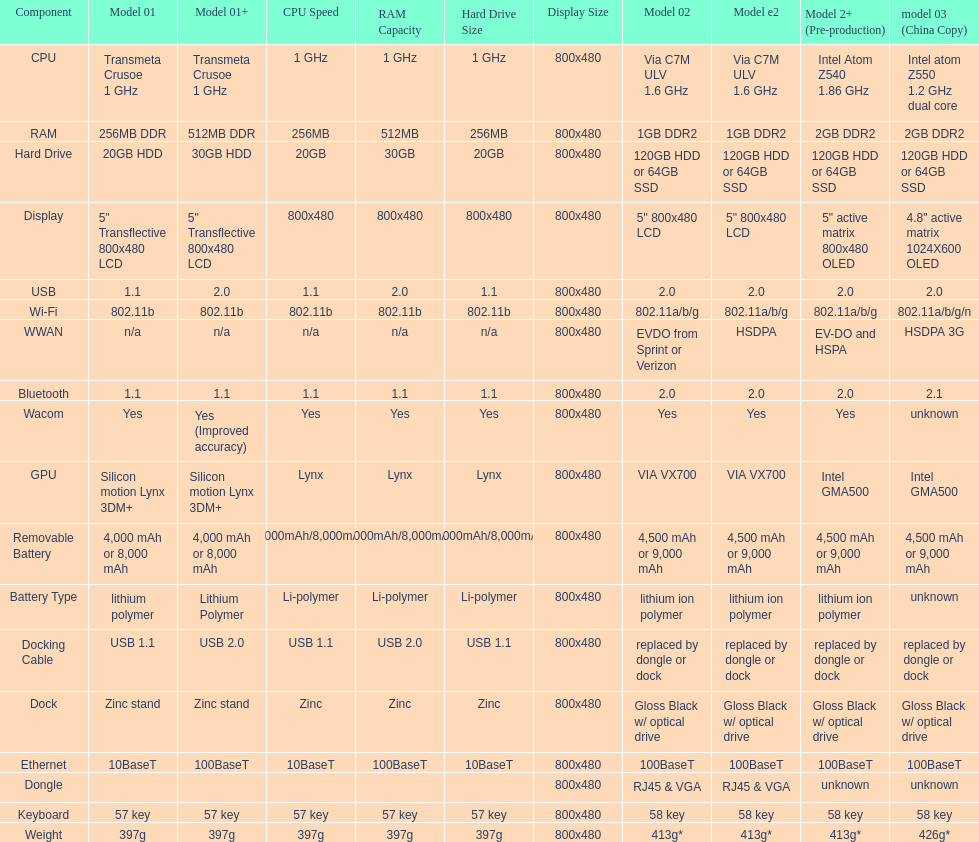Give me the full table as a dictionary. {'header': ['Component', 'Model 01', 'Model 01+', 'CPU Speed', 'RAM Capacity', 'Hard Drive Size', 'Display Size', 'Model 02', 'Model e2', 'Model 2+ (Pre-production)', 'model 03 (China Copy)'], 'rows': [['CPU', 'Transmeta Crusoe 1\xa0GHz', 'Transmeta Crusoe 1\xa0GHz', '1 GHz', '1 GHz', '1 GHz', '800x480', 'Via C7M ULV 1.6\xa0GHz', 'Via C7M ULV 1.6\xa0GHz', 'Intel Atom Z540 1.86\xa0GHz', 'Intel atom Z550 1.2\xa0GHz dual core'], ['RAM', '256MB DDR', '512MB DDR', '256MB', '512MB', '256MB', '800x480', '1GB DDR2', '1GB DDR2', '2GB DDR2', '2GB DDR2'], ['Hard Drive', '20GB HDD', '30GB HDD', '20GB', '30GB', '20GB', '800x480', '120GB HDD or 64GB SSD', '120GB HDD or 64GB SSD', '120GB HDD or 64GB SSD', '120GB HDD or 64GB SSD'], ['Display', '5" Transflective 800x480 LCD', '5" Transflective 800x480 LCD', '800x480', '800x480', '800x480', '800x480', '5" 800x480 LCD', '5" 800x480 LCD', '5" active matrix 800x480 OLED', '4.8" active matrix 1024X600 OLED'], ['USB', '1.1', '2.0', '1.1', '2.0', '1.1', '800x480', '2.0', '2.0', '2.0', '2.0'], ['Wi-Fi', '802.11b', '802.11b', '802.11b', '802.11b', '802.11b', '800x480', '802.11a/b/g', '802.11a/b/g', '802.11a/b/g', '802.11a/b/g/n'], ['WWAN', 'n/a', 'n/a', 'n/a', 'n/a', 'n/a', '800x480', 'EVDO from Sprint or Verizon', 'HSDPA', 'EV-DO and HSPA', 'HSDPA 3G'], ['Bluetooth', '1.1', '1.1', '1.1', '1.1', '1.1', '800x480', '2.0', '2.0', '2.0', '2.1'], ['Wacom', 'Yes', 'Yes (Improved accuracy)', 'Yes', 'Yes', 'Yes', '800x480', 'Yes', 'Yes', 'Yes', 'unknown'], ['GPU', 'Silicon motion Lynx 3DM+', 'Silicon motion Lynx 3DM+', 'Lynx', 'Lynx', 'Lynx', '800x480', 'VIA VX700', 'VIA VX700', 'Intel GMA500', 'Intel GMA500'], ['Removable Battery', '4,000 mAh or 8,000 mAh', '4,000 mAh or 8,000 mAh', '4,000mAh/8,000mAh', '4,000mAh/8,000mAh', '4,000mAh/8,000mAh', '800x480', '4,500 mAh or 9,000 mAh', '4,500 mAh or 9,000 mAh', '4,500 mAh or 9,000 mAh', '4,500 mAh or 9,000 mAh'], ['Battery Type', 'lithium polymer', 'Lithium Polymer', 'Li-polymer', 'Li-polymer', 'Li-polymer', '800x480', 'lithium ion polymer', 'lithium ion polymer', 'lithium ion polymer', 'unknown'], ['Docking Cable', 'USB 1.1', 'USB 2.0', 'USB 1.1', 'USB 2.0', 'USB 1.1', '800x480', 'replaced by dongle or dock', 'replaced by dongle or dock', 'replaced by dongle or dock', 'replaced by dongle or dock'], ['Dock', 'Zinc stand', 'Zinc stand', 'Zinc', 'Zinc', 'Zinc', '800x480', 'Gloss Black w/ optical drive', 'Gloss Black w/ optical drive', 'Gloss Black w/ optical drive', 'Gloss Black w/ optical drive'], ['Ethernet', '10BaseT', '100BaseT', '10BaseT', '100BaseT', '10BaseT', '800x480', '100BaseT', '100BaseT', '100BaseT', '100BaseT'], ['Dongle', '', '', '', '', '', '800x480', 'RJ45 & VGA', 'RJ45 & VGA', 'unknown', 'unknown'], ['Keyboard', '57 key', '57 key', '57 key', '57 key', '57 key', '800x480', '58 key', '58 key', '58 key', '58 key'], ['Weight', '397g', '397g', '397g', '397g', '397g', '800x480', '413g*', '413g*', '413g*', '426g*']]} What is the next highest hard drive available after the 30gb model? 64GB SSD. 